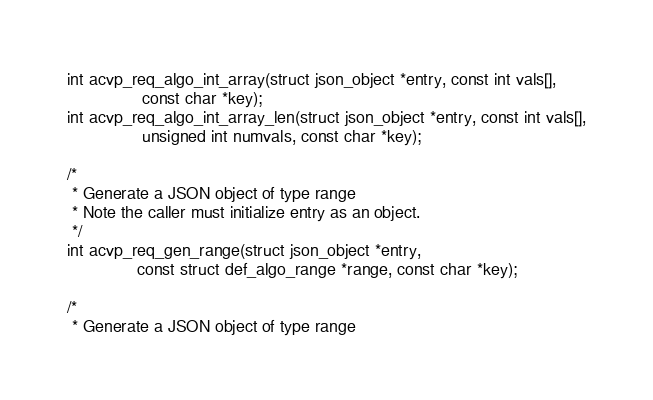Convert code to text. <code><loc_0><loc_0><loc_500><loc_500><_C_>int acvp_req_algo_int_array(struct json_object *entry, const int vals[],
			    const char *key);
int acvp_req_algo_int_array_len(struct json_object *entry, const int vals[],
				unsigned int numvals, const char *key);

/*
 * Generate a JSON object of type range
 * Note the caller must initialize entry as an object.
 */
int acvp_req_gen_range(struct json_object *entry,
		       const struct def_algo_range *range, const char *key);

/*
 * Generate a JSON object of type range</code> 